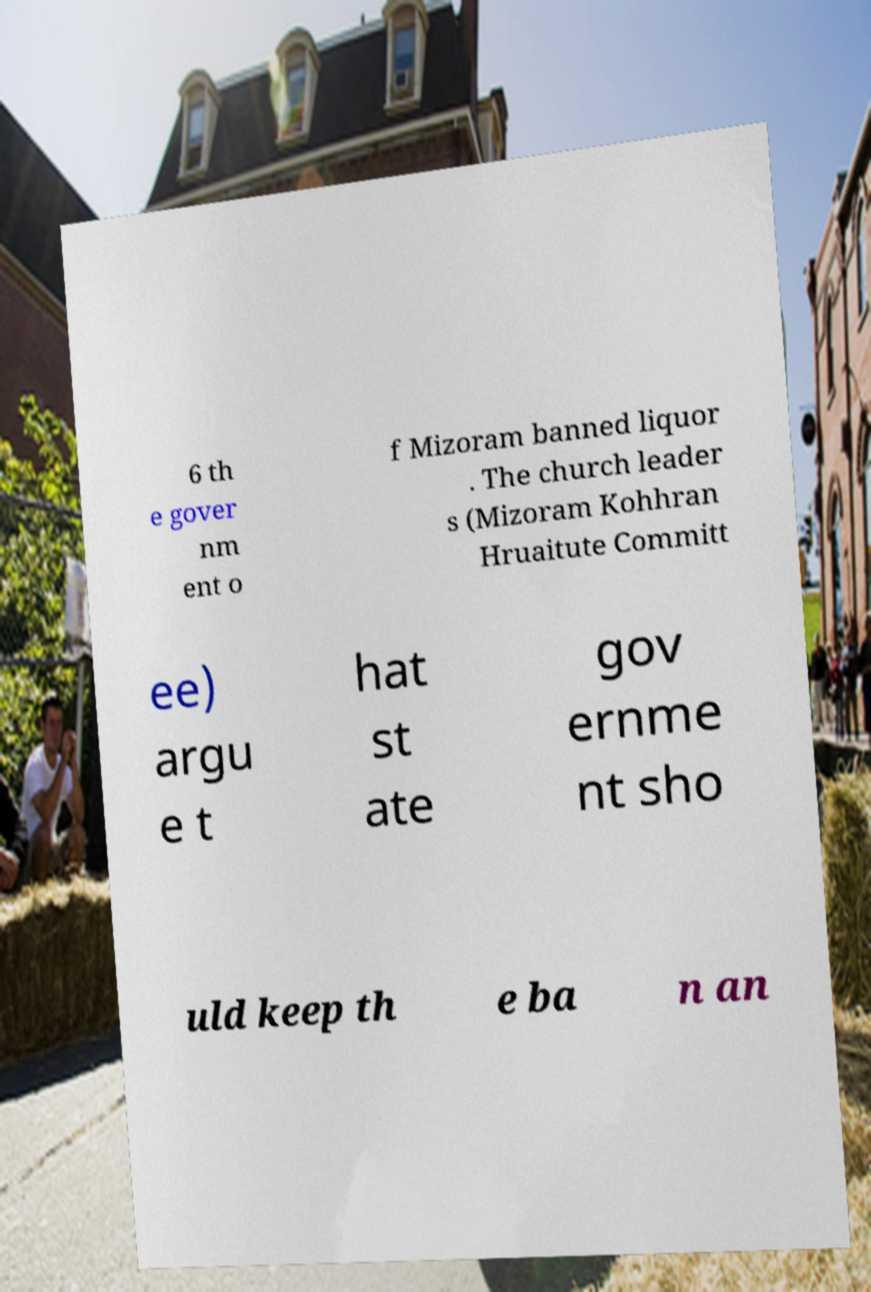For documentation purposes, I need the text within this image transcribed. Could you provide that? 6 th e gover nm ent o f Mizoram banned liquor . The church leader s (Mizoram Kohhran Hruaitute Committ ee) argu e t hat st ate gov ernme nt sho uld keep th e ba n an 